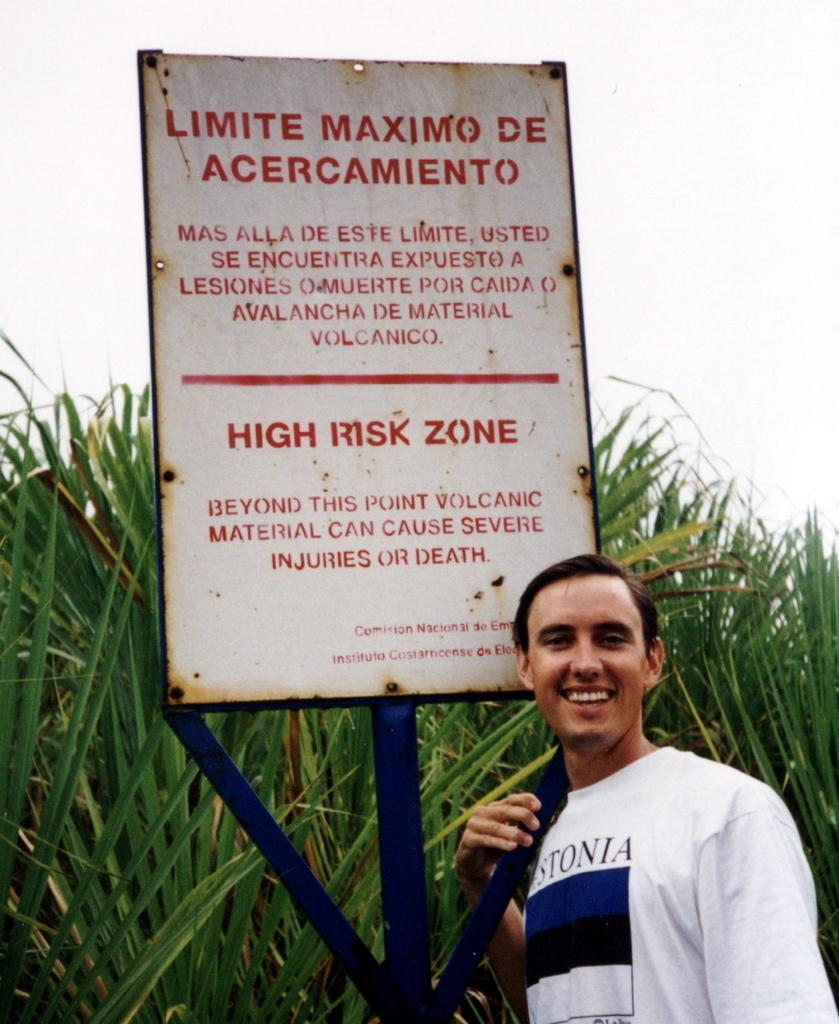<image>
Create a compact narrative representing the image presented. The man stands in front of a sign that warns he is in a high risk zone. 